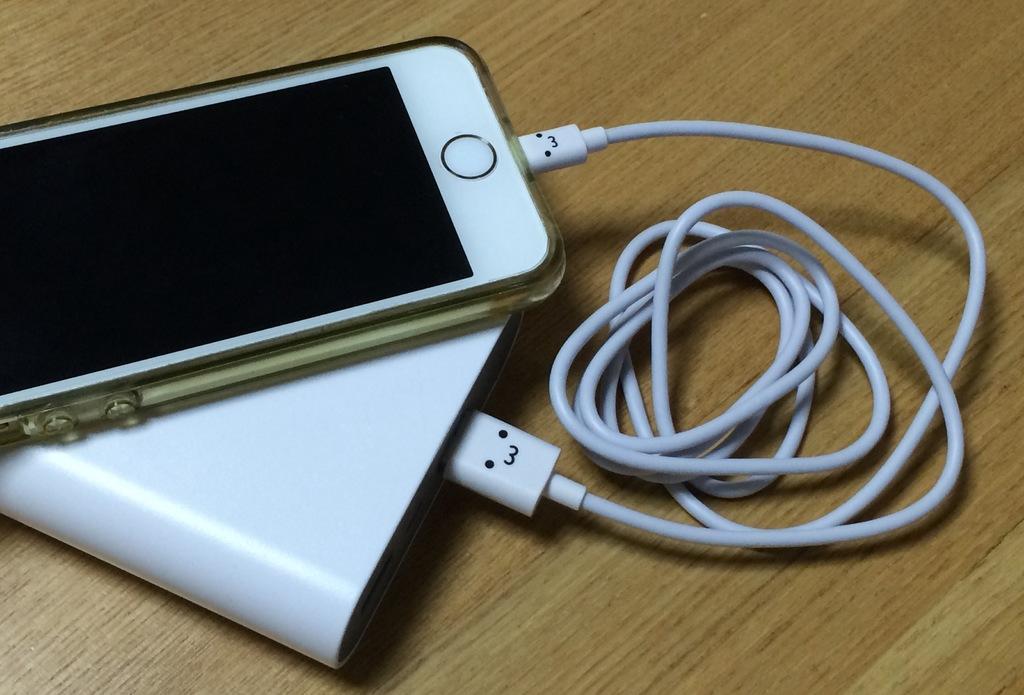Could you give a brief overview of what you see in this image? In this image there is a mobile, power bank and a cable on a table. 